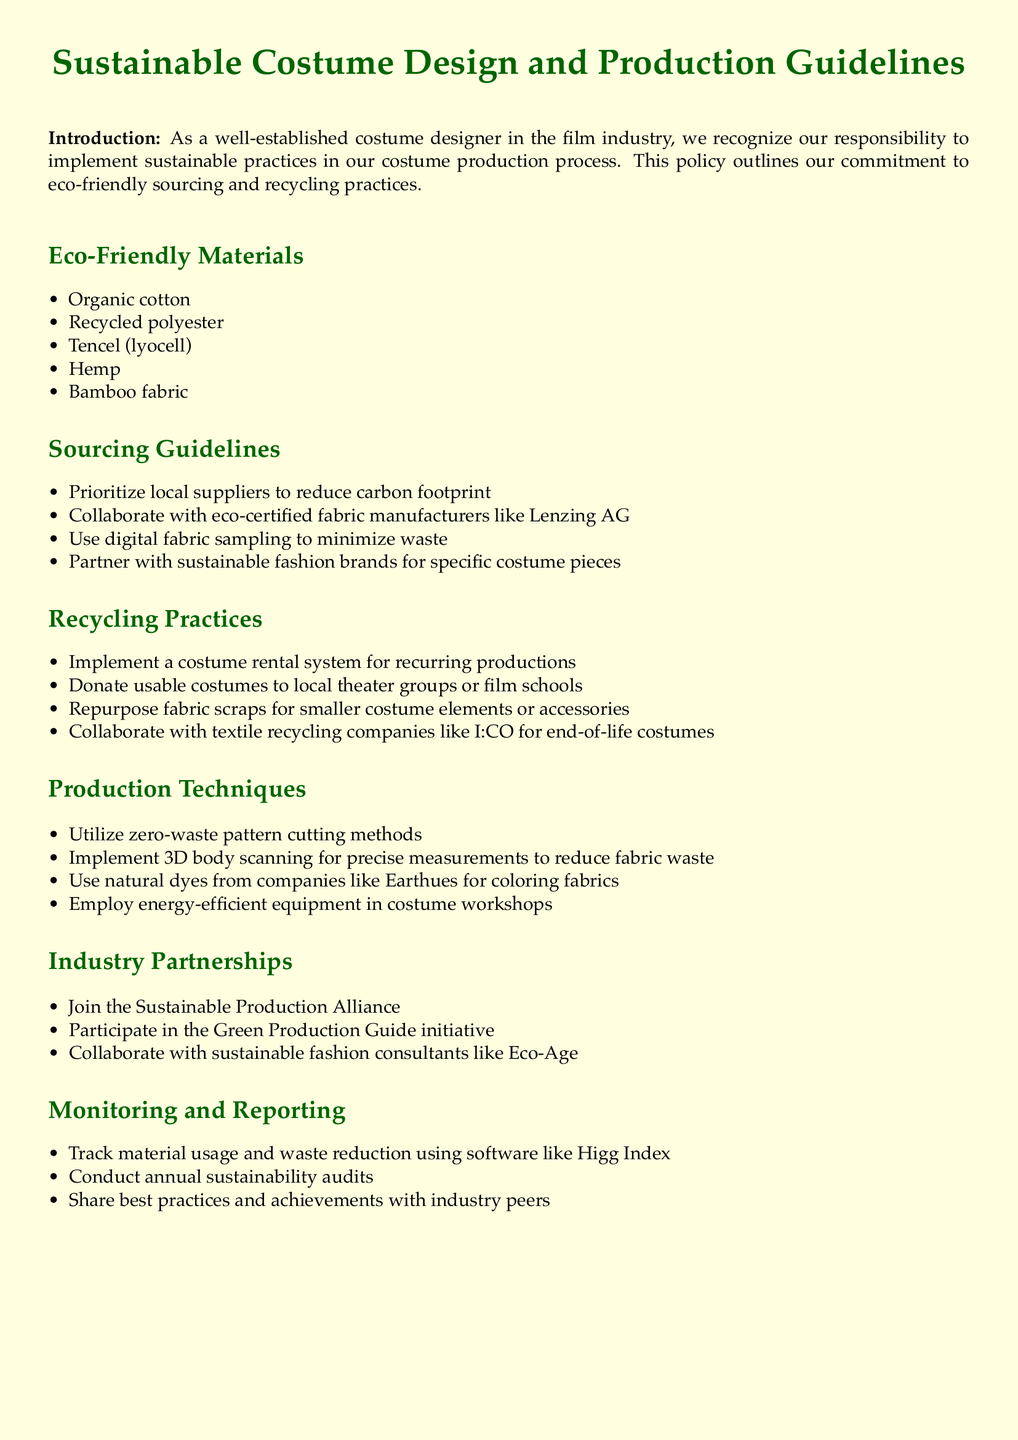What are some eco-friendly materials mentioned? The document lists multiple eco-friendly materials used in costume production. They include organic cotton, recycled polyester, Tencel, hemp, and bamboo fabric.
Answer: Organic cotton, recycled polyester, Tencel, hemp, bamboo fabric What should be prioritized when sourcing materials? The sourcing guidelines specify prioritizing a specific type of supplier to reduce carbon footprint.
Answer: Local suppliers Which fabric manufacturer is eco-certified? The document mentions a specific eco-certified fabric manufacturer that should be collaborated with.
Answer: Lenzing AG What system should be implemented for recurring productions? The recycling practices section suggests a specific system to manage costumes for repeated use in productions.
Answer: Costume rental system Name one method to reduce fabric waste in production techniques. The production techniques section describes a specific method aimed at minimizing waste during costume cutting.
Answer: Zero-waste pattern cutting methods Which initiative should one participate in as part of industry partnerships? The document lists a specific sustainability initiative that costume designers should engage with.
Answer: Green Production Guide What tool can be used to track material usage? The monitoring and reporting section highlights a software that can track material usage and waste reduction.
Answer: Higg Index How often should sustainability audits be conducted? The document specifies the frequency for a specific type of audit related to sustainability.
Answer: Annually 